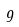Convert formula to latex. <formula><loc_0><loc_0><loc_500><loc_500>9</formula> 